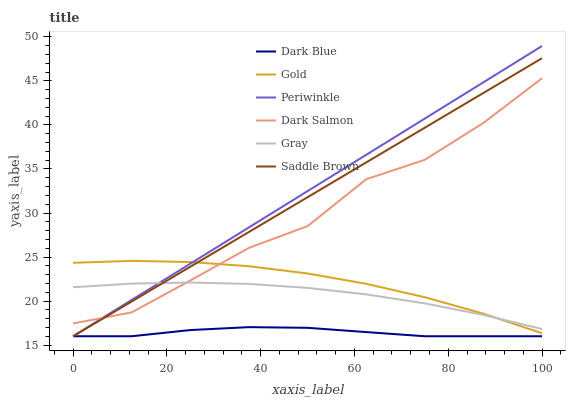Does Dark Blue have the minimum area under the curve?
Answer yes or no. Yes. Does Periwinkle have the maximum area under the curve?
Answer yes or no. Yes. Does Gold have the minimum area under the curve?
Answer yes or no. No. Does Gold have the maximum area under the curve?
Answer yes or no. No. Is Periwinkle the smoothest?
Answer yes or no. Yes. Is Dark Salmon the roughest?
Answer yes or no. Yes. Is Gold the smoothest?
Answer yes or no. No. Is Gold the roughest?
Answer yes or no. No. Does Dark Blue have the lowest value?
Answer yes or no. Yes. Does Gold have the lowest value?
Answer yes or no. No. Does Periwinkle have the highest value?
Answer yes or no. Yes. Does Gold have the highest value?
Answer yes or no. No. Is Dark Blue less than Dark Salmon?
Answer yes or no. Yes. Is Dark Salmon greater than Dark Blue?
Answer yes or no. Yes. Does Gray intersect Periwinkle?
Answer yes or no. Yes. Is Gray less than Periwinkle?
Answer yes or no. No. Is Gray greater than Periwinkle?
Answer yes or no. No. Does Dark Blue intersect Dark Salmon?
Answer yes or no. No. 